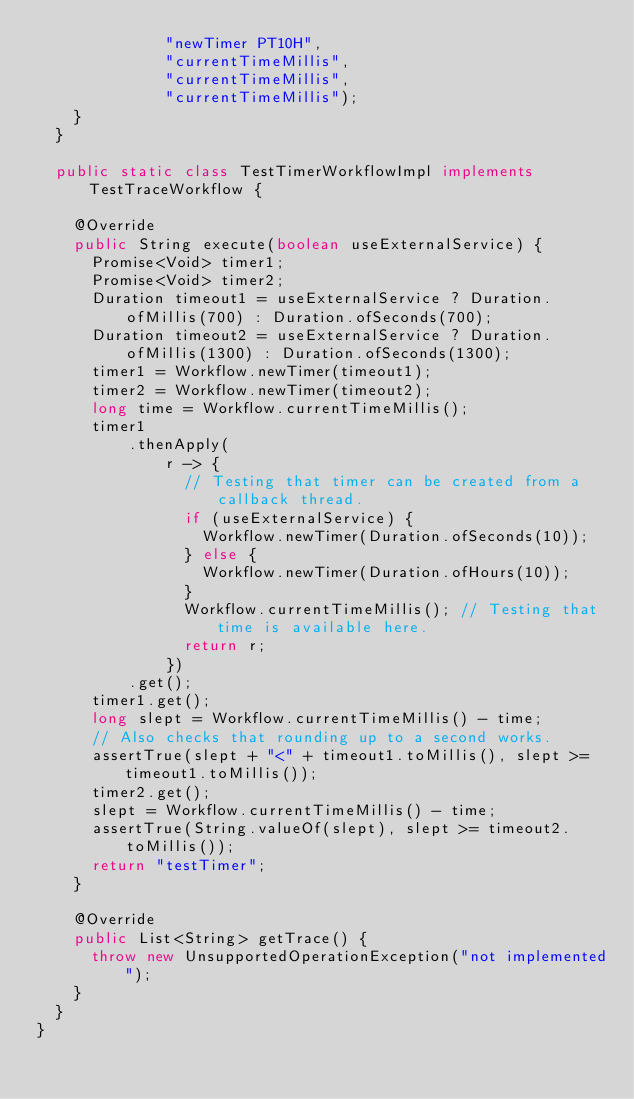Convert code to text. <code><loc_0><loc_0><loc_500><loc_500><_Java_>              "newTimer PT10H",
              "currentTimeMillis",
              "currentTimeMillis",
              "currentTimeMillis");
    }
  }

  public static class TestTimerWorkflowImpl implements TestTraceWorkflow {

    @Override
    public String execute(boolean useExternalService) {
      Promise<Void> timer1;
      Promise<Void> timer2;
      Duration timeout1 = useExternalService ? Duration.ofMillis(700) : Duration.ofSeconds(700);
      Duration timeout2 = useExternalService ? Duration.ofMillis(1300) : Duration.ofSeconds(1300);
      timer1 = Workflow.newTimer(timeout1);
      timer2 = Workflow.newTimer(timeout2);
      long time = Workflow.currentTimeMillis();
      timer1
          .thenApply(
              r -> {
                // Testing that timer can be created from a callback thread.
                if (useExternalService) {
                  Workflow.newTimer(Duration.ofSeconds(10));
                } else {
                  Workflow.newTimer(Duration.ofHours(10));
                }
                Workflow.currentTimeMillis(); // Testing that time is available here.
                return r;
              })
          .get();
      timer1.get();
      long slept = Workflow.currentTimeMillis() - time;
      // Also checks that rounding up to a second works.
      assertTrue(slept + "<" + timeout1.toMillis(), slept >= timeout1.toMillis());
      timer2.get();
      slept = Workflow.currentTimeMillis() - time;
      assertTrue(String.valueOf(slept), slept >= timeout2.toMillis());
      return "testTimer";
    }

    @Override
    public List<String> getTrace() {
      throw new UnsupportedOperationException("not implemented");
    }
  }
}
</code> 